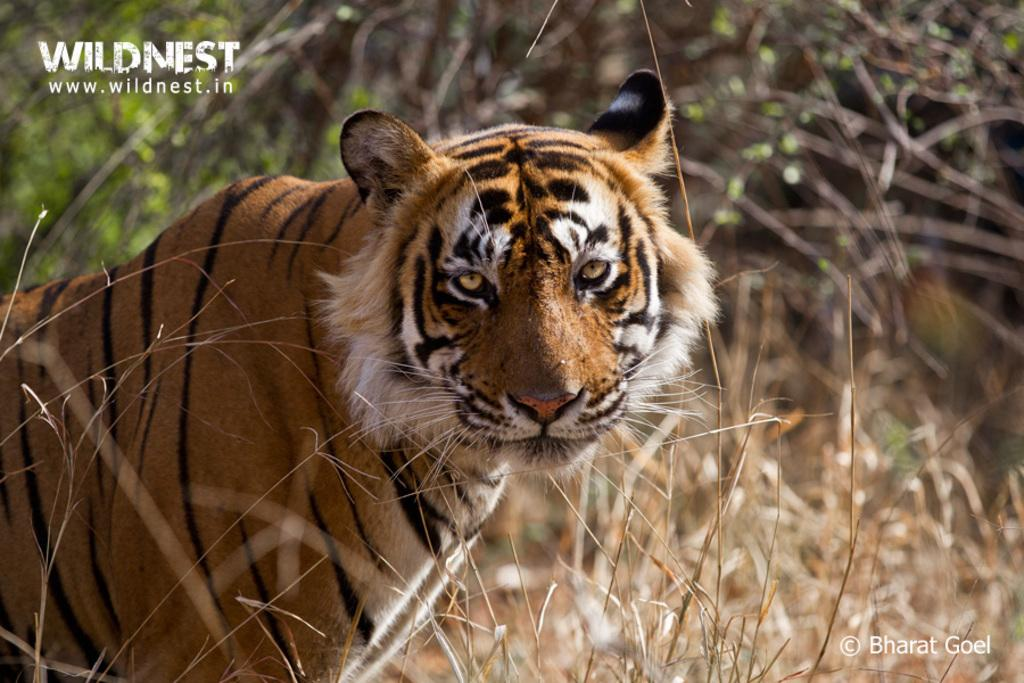What animal is on the path in the image? There is a tiger on the path in the image. What can be seen behind the tiger in the image? There are trees behind the tiger in the image. Can you describe any additional features of the image? The image has watermarks. What type of powder is being used by the tiger to play in the image? There is no powder or play activity involving the tiger in the image. 